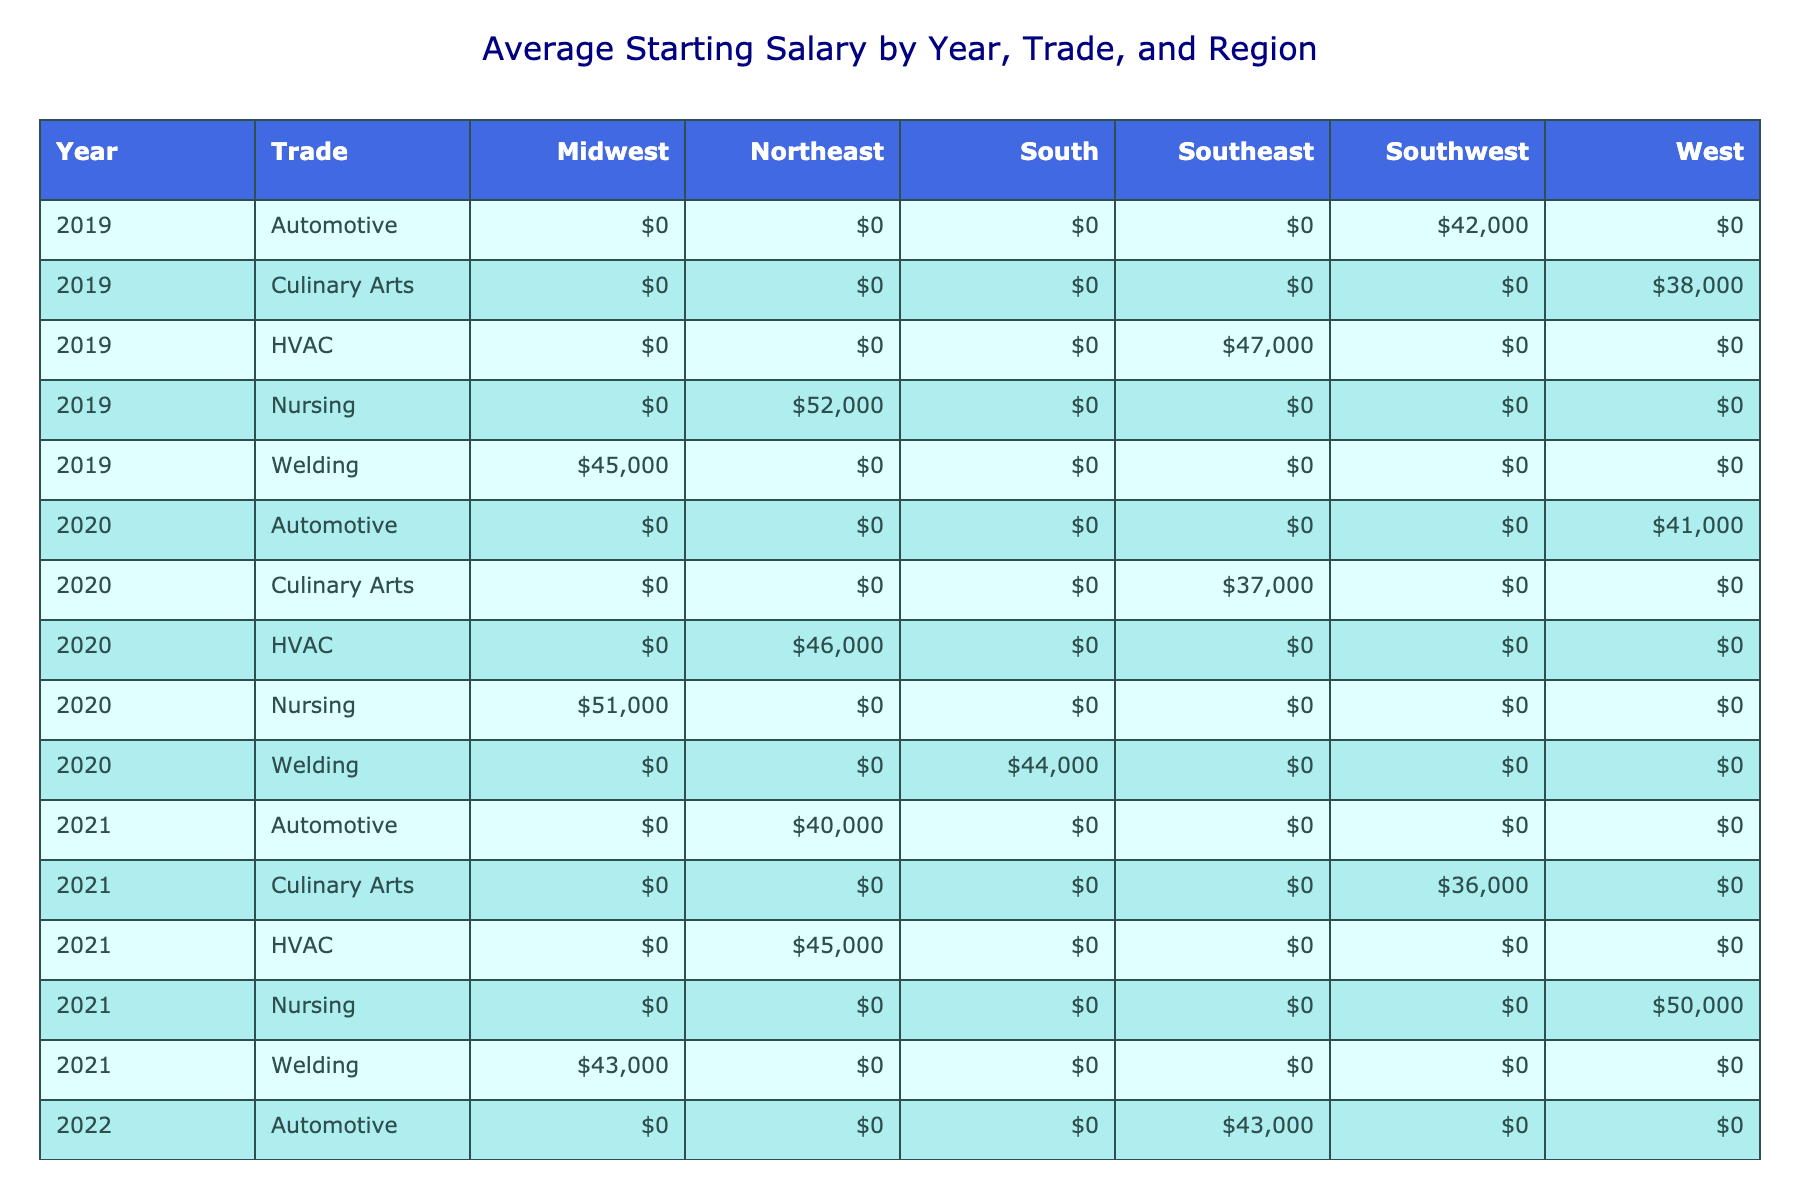What was the highest average starting salary for vocational school graduates in 2022? The table shows that in 2022, the highest average starting salary is from the Nursing trade, with an average starting salary of $53,000.
Answer: $53,000 What was the employment rate for Culinary Arts graduates in 2021? From the table, the employment rate for Culinary Arts graduates in 2021 is 84%.
Answer: 84% Which trade had the lowest job placement rate in 2020? In 2020, Automotive graduates from WyoTech had the lowest job placement rate of 83%.
Answer: 83% What is the average starting salary for Welding graduates across all years? Adding up the average starting salaries for Welding graduates from 2019 to 2023: 45,000 (2019) + 44,000 (2020) + 43,000 (2021) + 46,000 (2022) + 47,000 (2023) = 225,000. Dividing by 5 gives an average of 45,000.
Answer: $45,000 Did the employment rate for Nursing graduates improve from 2020 to 2023? Yes, the employment rate for Nursing graduates improved from 94% in 2020 to 97% in 2023.
Answer: Yes What trade showed the most significant improvement in average starting salary from 2019 to 2023? For HVAC, the average starting salary increased from $47,000 in 2019 to $49,000 in 2023, which is a difference of $2,000. Conversely, for Nursing, it went from $52,000 to $54,000, which is a $2,000 improvement as well. However, considering other trades like Automotive went from $42,000 to $44,000, they also show improvement, but less than that of HVAC. Thus, HVAC and Nursing are tied in improvement.
Answer: HVAC and Nursing show the most improvement with $2,000 What is the total employment rate for the HVAC trade across all listed years? The employment rates for HVAC over the years are 91% (2019), 89% (2020), 87% (2021), 90% (2022), and 92% (2023). Summing these gives: 91 + 89 + 87 + 90 + 92 = 449. The average is 449/5 = 89.8%, which can be rounded down to 90%.
Answer: 90% Were all vocational trades able to reach an employment rate above 85% in 2023? Yes, all trades listed (Welding, Automotive, Nursing, HVAC, Culinary Arts) achieved employment rates above 85% in 2023.
Answer: Yes 